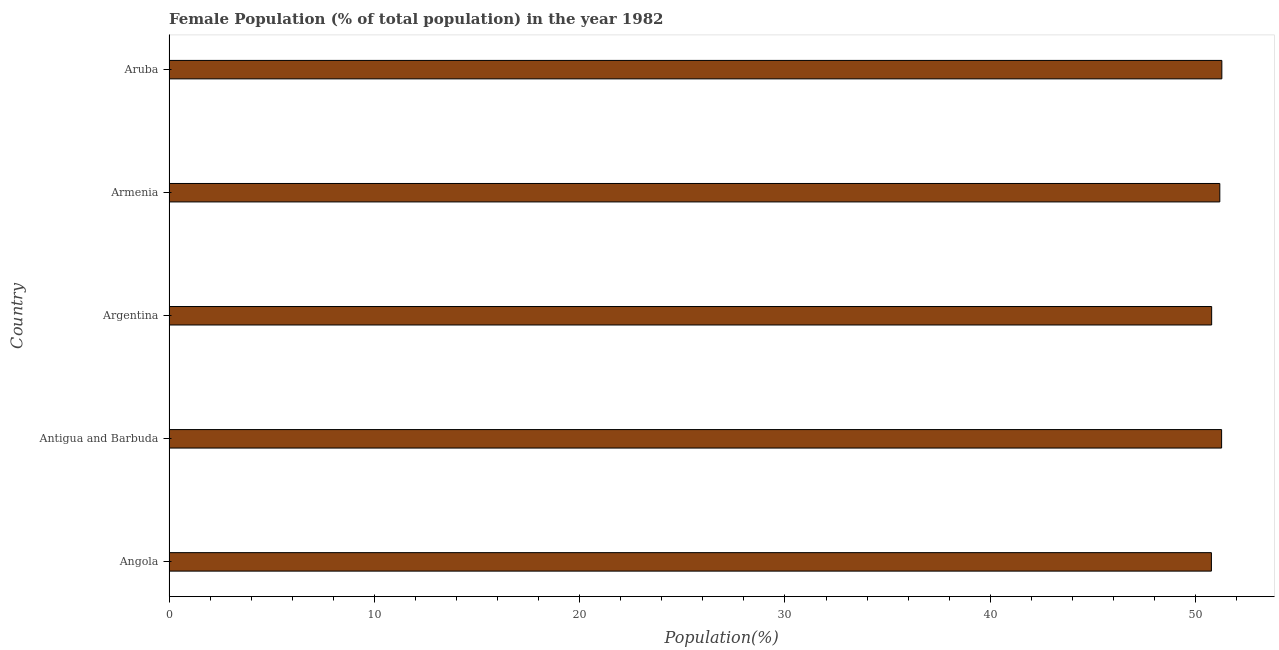Does the graph contain any zero values?
Keep it short and to the point. No. What is the title of the graph?
Ensure brevity in your answer.  Female Population (% of total population) in the year 1982. What is the label or title of the X-axis?
Give a very brief answer. Population(%). What is the label or title of the Y-axis?
Give a very brief answer. Country. What is the female population in Antigua and Barbuda?
Keep it short and to the point. 51.27. Across all countries, what is the maximum female population?
Your answer should be very brief. 51.28. Across all countries, what is the minimum female population?
Your answer should be compact. 50.77. In which country was the female population maximum?
Provide a short and direct response. Aruba. In which country was the female population minimum?
Give a very brief answer. Angola. What is the sum of the female population?
Your response must be concise. 255.27. What is the difference between the female population in Angola and Armenia?
Make the answer very short. -0.41. What is the average female population per country?
Offer a very short reply. 51.05. What is the median female population?
Your answer should be very brief. 51.18. Is the female population in Angola less than that in Armenia?
Ensure brevity in your answer.  Yes. Is the difference between the female population in Angola and Argentina greater than the difference between any two countries?
Provide a succinct answer. No. What is the difference between the highest and the second highest female population?
Your response must be concise. 0.01. Is the sum of the female population in Angola and Armenia greater than the maximum female population across all countries?
Provide a succinct answer. Yes. What is the difference between the highest and the lowest female population?
Your answer should be compact. 0.51. In how many countries, is the female population greater than the average female population taken over all countries?
Keep it short and to the point. 3. Are all the bars in the graph horizontal?
Provide a short and direct response. Yes. How many countries are there in the graph?
Ensure brevity in your answer.  5. What is the difference between two consecutive major ticks on the X-axis?
Your answer should be compact. 10. Are the values on the major ticks of X-axis written in scientific E-notation?
Offer a very short reply. No. What is the Population(%) of Angola?
Ensure brevity in your answer.  50.77. What is the Population(%) in Antigua and Barbuda?
Give a very brief answer. 51.27. What is the Population(%) in Argentina?
Provide a succinct answer. 50.78. What is the Population(%) of Armenia?
Your answer should be compact. 51.18. What is the Population(%) in Aruba?
Your answer should be very brief. 51.28. What is the difference between the Population(%) in Angola and Antigua and Barbuda?
Provide a short and direct response. -0.5. What is the difference between the Population(%) in Angola and Argentina?
Provide a short and direct response. -0.01. What is the difference between the Population(%) in Angola and Armenia?
Offer a terse response. -0.41. What is the difference between the Population(%) in Angola and Aruba?
Provide a short and direct response. -0.51. What is the difference between the Population(%) in Antigua and Barbuda and Argentina?
Your answer should be compact. 0.48. What is the difference between the Population(%) in Antigua and Barbuda and Armenia?
Your response must be concise. 0.09. What is the difference between the Population(%) in Antigua and Barbuda and Aruba?
Keep it short and to the point. -0.01. What is the difference between the Population(%) in Argentina and Armenia?
Your response must be concise. -0.4. What is the difference between the Population(%) in Argentina and Aruba?
Give a very brief answer. -0.5. What is the difference between the Population(%) in Armenia and Aruba?
Your answer should be very brief. -0.1. What is the ratio of the Population(%) in Angola to that in Argentina?
Make the answer very short. 1. What is the ratio of the Population(%) in Angola to that in Armenia?
Offer a terse response. 0.99. What is the ratio of the Population(%) in Antigua and Barbuda to that in Argentina?
Your response must be concise. 1.01. What is the ratio of the Population(%) in Antigua and Barbuda to that in Armenia?
Offer a terse response. 1. What is the ratio of the Population(%) in Argentina to that in Aruba?
Offer a terse response. 0.99. What is the ratio of the Population(%) in Armenia to that in Aruba?
Ensure brevity in your answer.  1. 